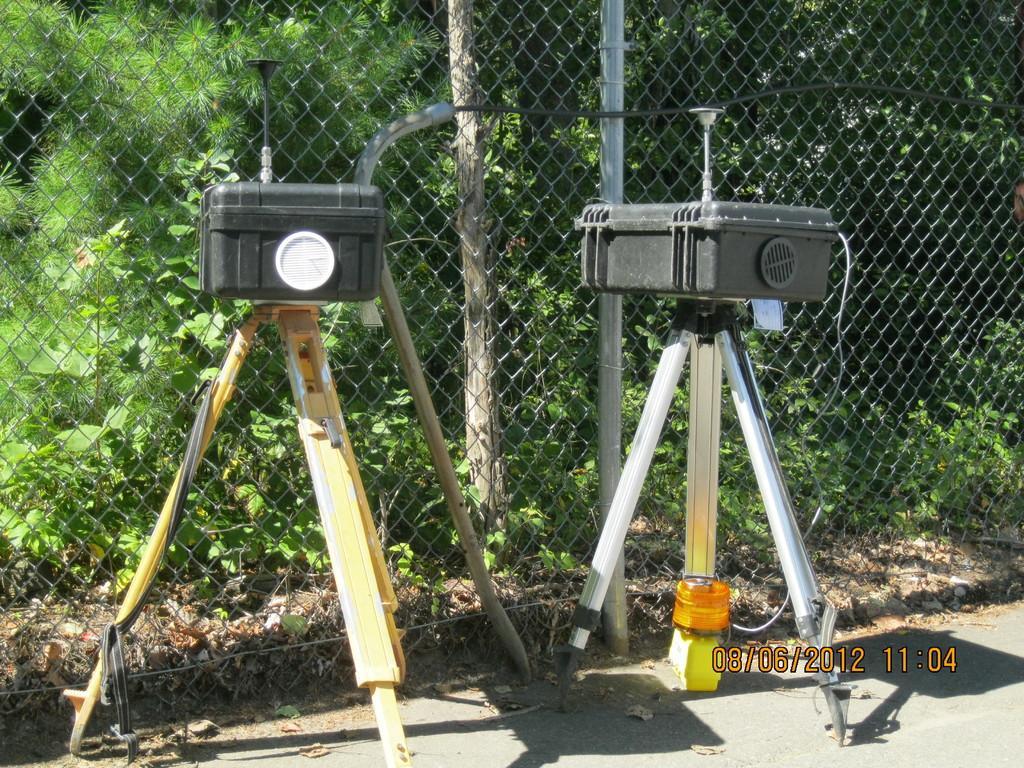Please provide a concise description of this image. In this image we can see some devices on the tripods which are placed on the ground. On the backside we can see a wooden pole, a metal fence, some plants and a group of trees. 